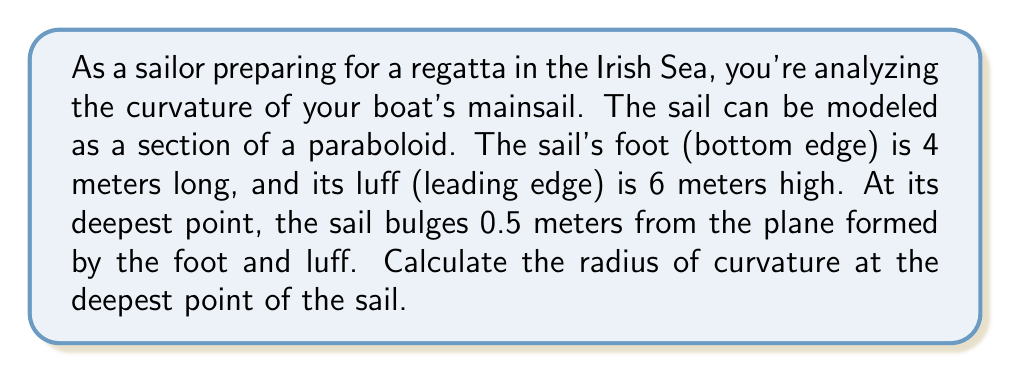Could you help me with this problem? To solve this problem, we'll follow these steps:

1) First, let's set up a coordinate system. We'll place the origin at one corner of the sail, with the x-axis along the foot, the y-axis along the luff, and the z-axis perpendicular to the sail's plane.

2) The equation of a paraboloid can be written as:

   $$z = a(x^2 + y^2)$$

   where $a$ is a constant we need to determine.

3) We know that at the deepest point (2, 3, 0.5), the z-value is 0.5. Substituting this into our equation:

   $$0.5 = a(2^2 + 3^2) = a(13)$$

4) Solving for $a$:

   $$a = \frac{0.5}{13} \approx 0.0385$$

5) Now that we have the equation of our paraboloid, we can calculate the curvature. The formula for the Gaussian curvature (K) of a paraboloid at its vertex is:

   $$K = 4a^2$$

6) Substituting our value of $a$:

   $$K = 4(0.0385)^2 \approx 0.005929$$

7) The radius of curvature (R) is the reciprocal of the square root of the Gaussian curvature:

   $$R = \frac{1}{\sqrt{K}} = \frac{1}{\sqrt{0.005929}} \approx 12.99$$

[asy]
import graph3;
size(200,200,IgnoreAspect);
currentprojection=perspective(6,3,2);
real f(pair z) {return 0.0385*(z.x^2+z.y^2);}
surface s=surface(f,(0,0),(4,6),50);
draw(s,paleblue);
draw((0,0,0)--(4,0,0)--(4,6,0)--(0,6,0)--cycle);
draw((2,3,0)--(2,3,0.5),red);
label("0.5m",((2,3,0.25)),E);
label("4m",(2,0,0),S);
label("6m",(4,3,0),E);
[/asy]
Answer: The radius of curvature at the deepest point of the sail is approximately 13 meters. 